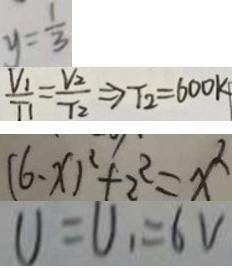Convert formula to latex. <formula><loc_0><loc_0><loc_500><loc_500>y = \frac { 1 } { 3 } 
 \frac { V _ { 1 } } { T _ { 1 } } = \frac { V _ { 2 } } { T _ { 2 } } \Rightarrow T _ { 2 } = 6 0 0 k 
 ( 6 - x ) ^ { 2 } + 2 ^ { 2 } = x ^ { 2 } 
 U = U _ { 1 } = 6 V</formula> 